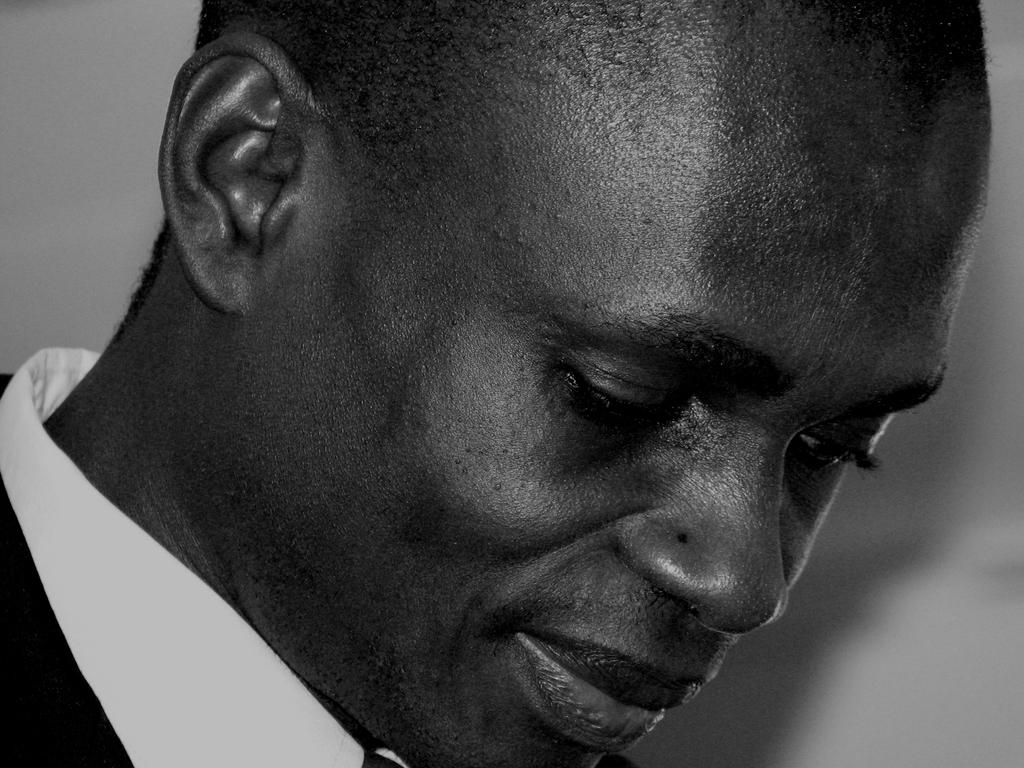What is present in the image? There is a man in the image. Can you describe the man's expression? The man is smiling. What type of vehicle is the man driving in the image? There is no vehicle present in the image; it only features a man who is smiling. 